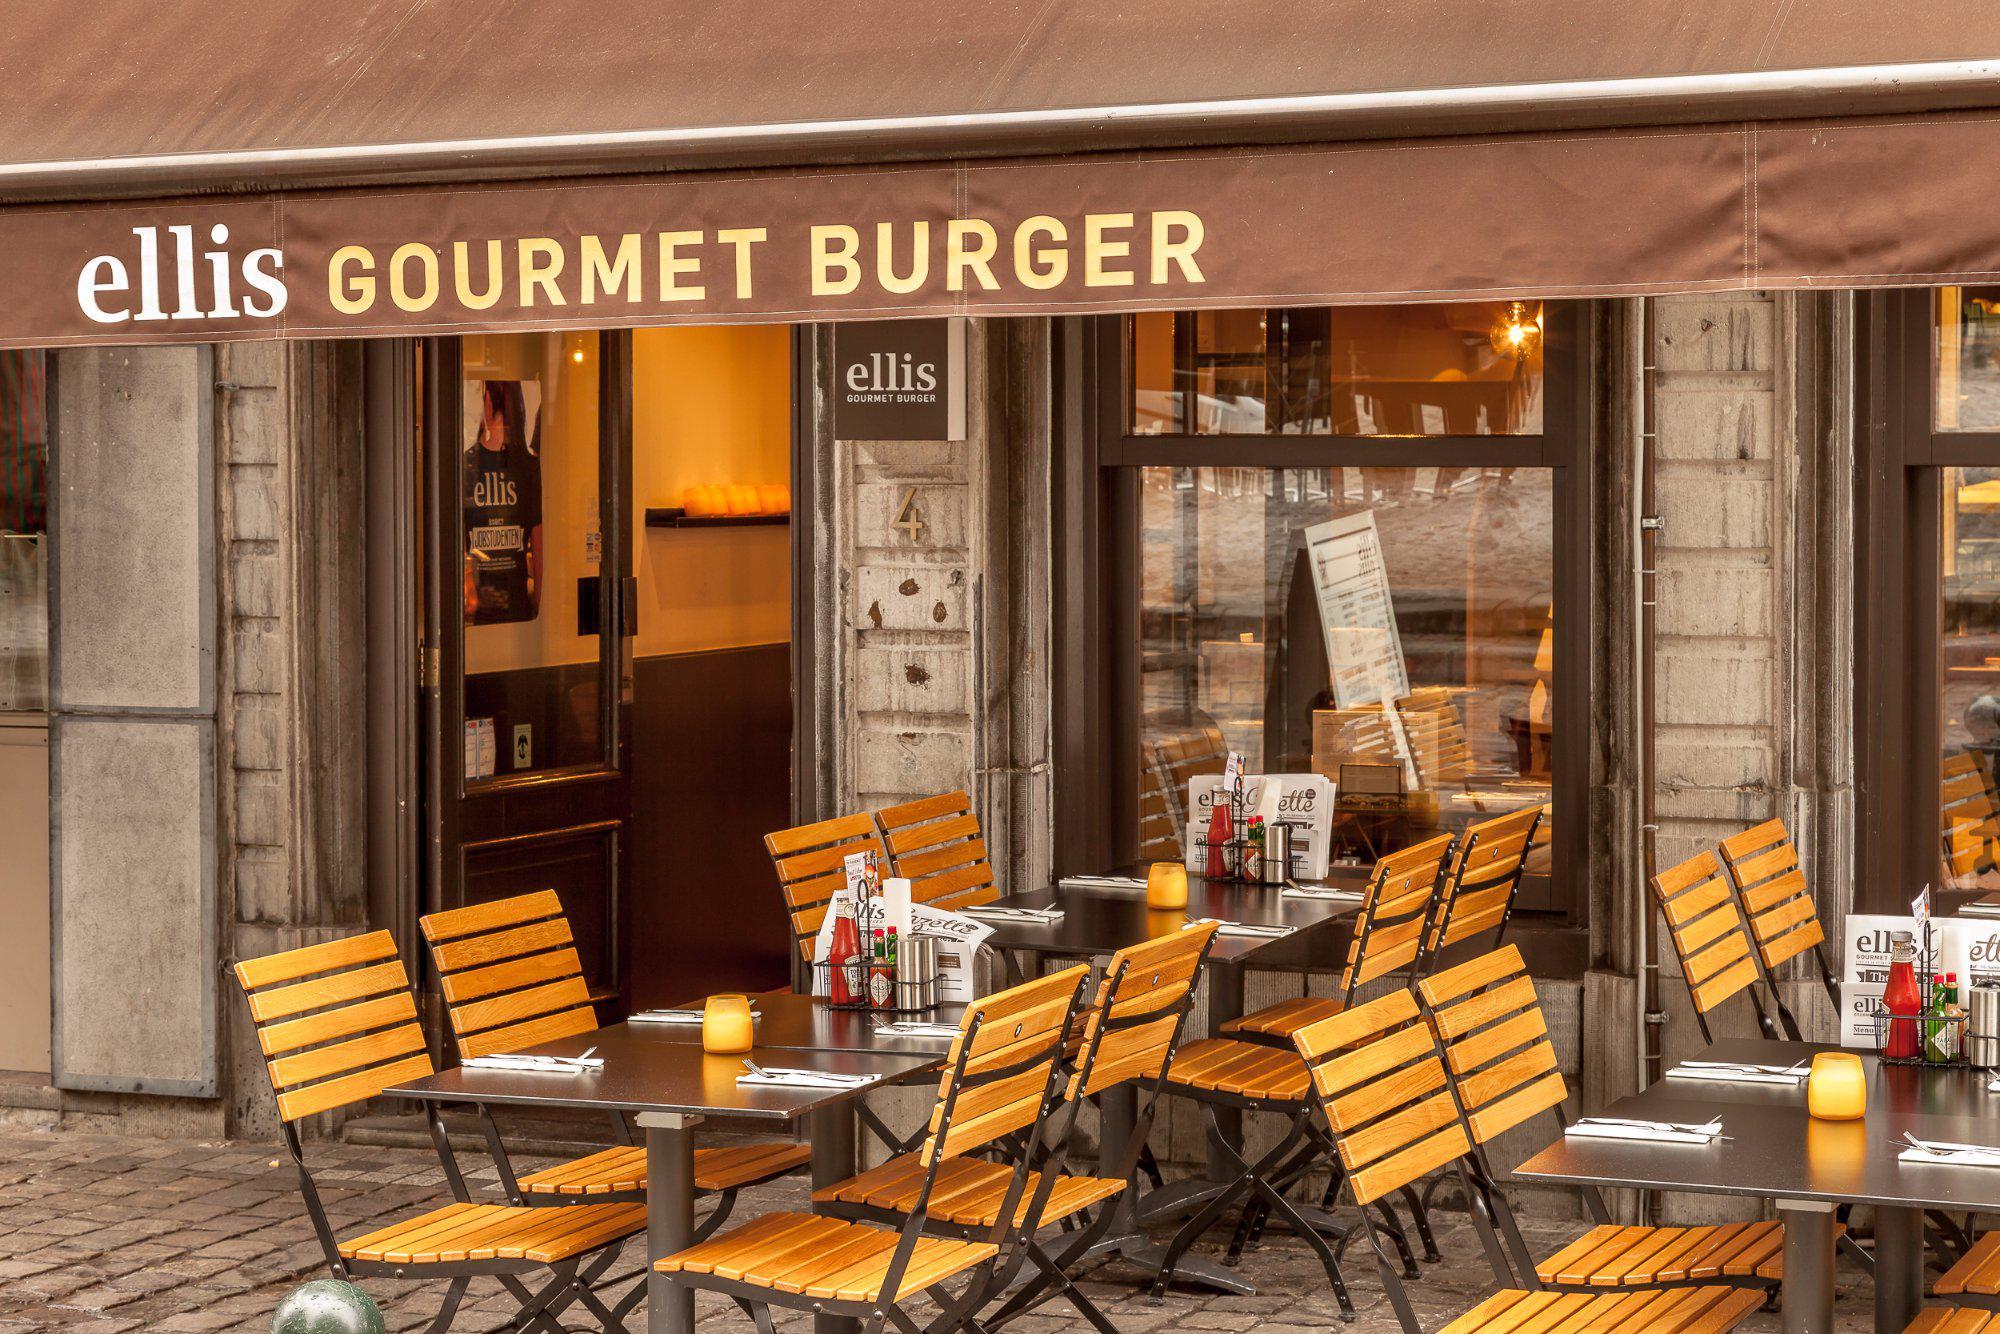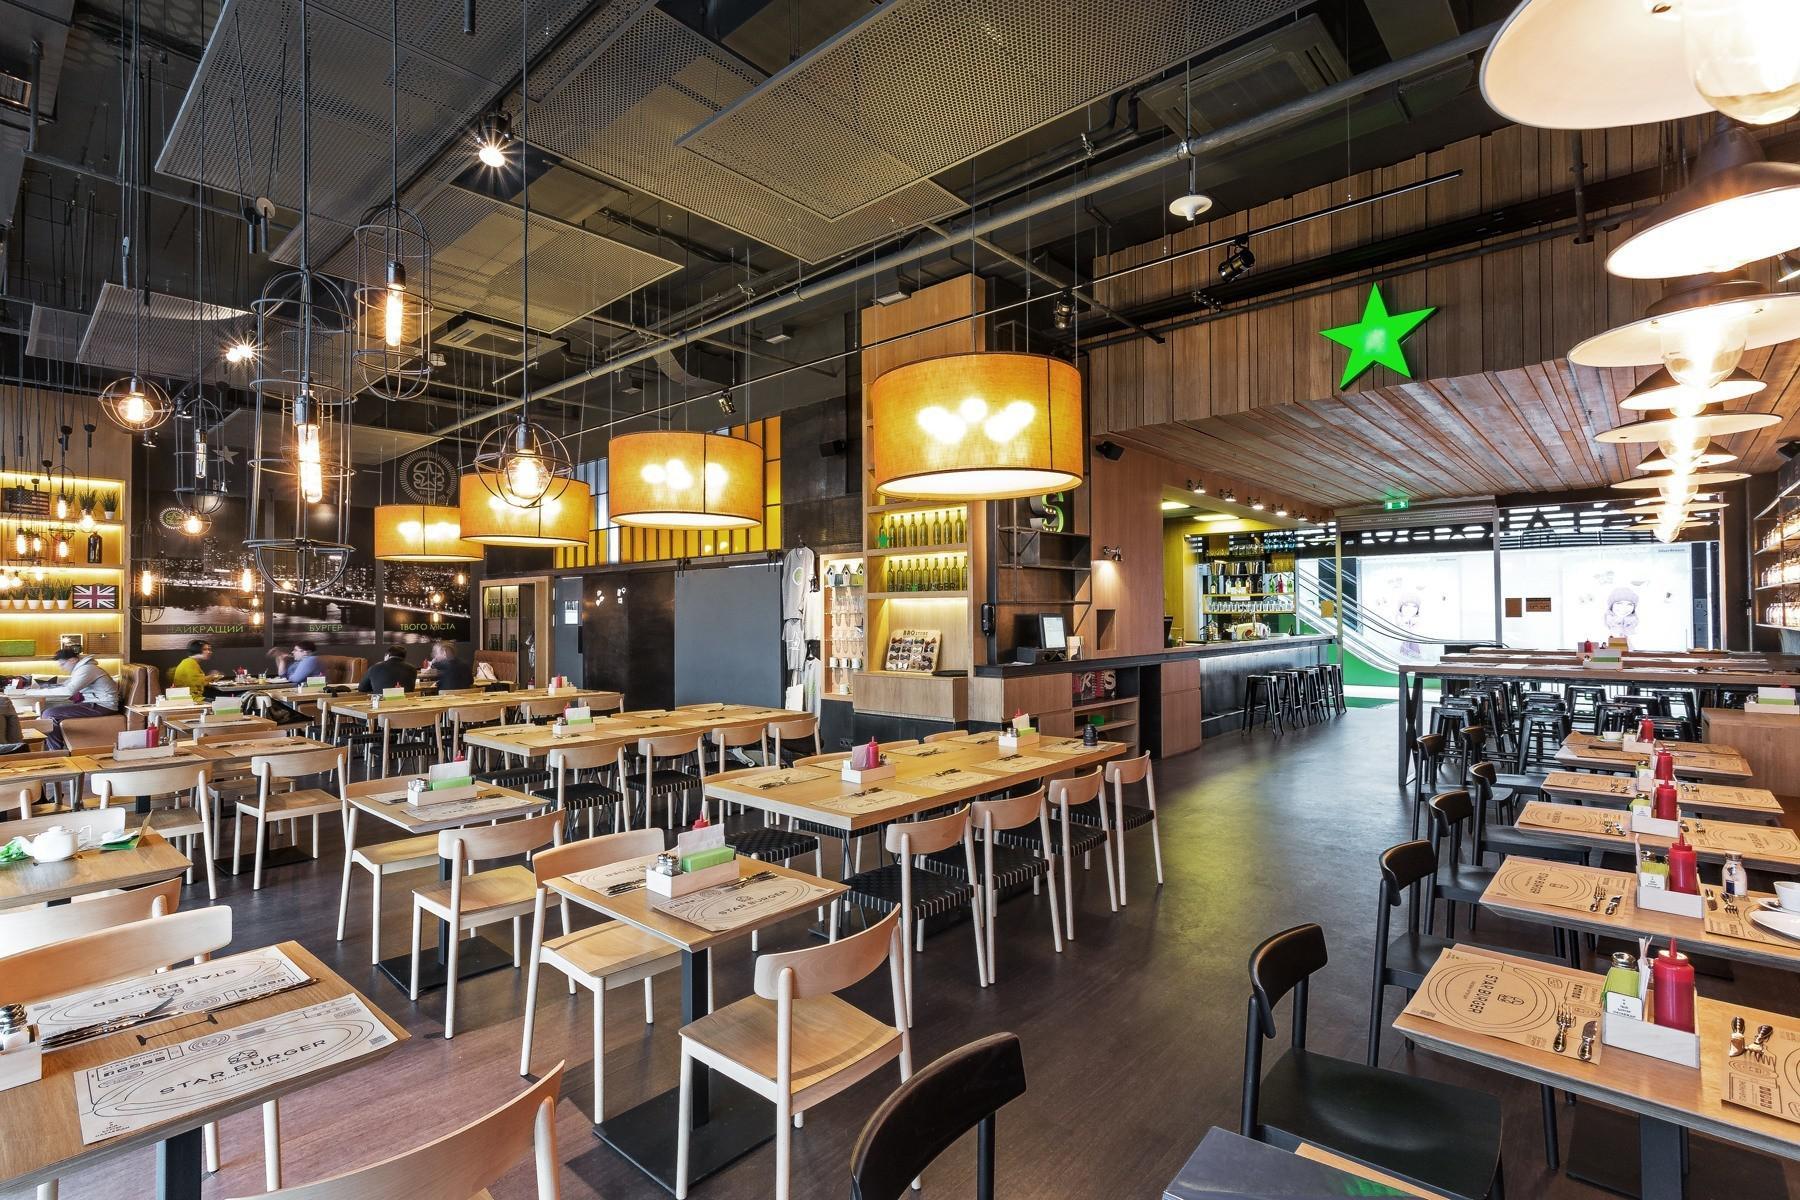The first image is the image on the left, the second image is the image on the right. Considering the images on both sides, is "There are people in the right image but not in the left image." valid? Answer yes or no. Yes. The first image is the image on the left, the second image is the image on the right. Examine the images to the left and right. Is the description "There are two restaurants will all of its seats empty." accurate? Answer yes or no. Yes. 